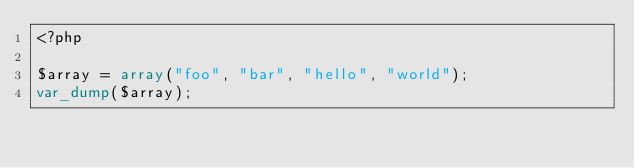<code> <loc_0><loc_0><loc_500><loc_500><_PHP_><?php

$array = array("foo", "bar", "hello", "world");
var_dump($array);</code> 